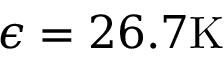Convert formula to latex. <formula><loc_0><loc_0><loc_500><loc_500>\epsilon = 2 6 . 7 K</formula> 